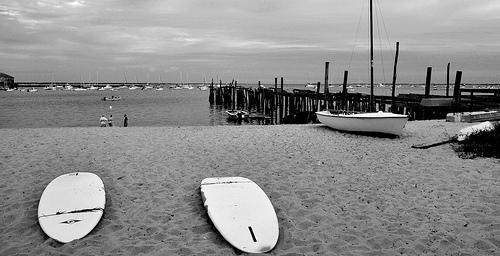How many boats in the image are on the beach?
Give a very brief answer. 1. 